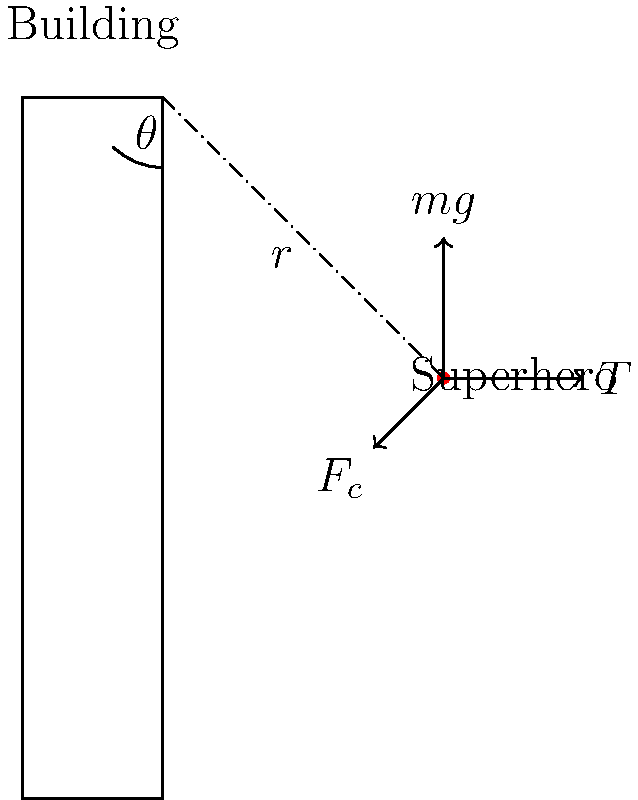Spider-Man is swinging around a building using his web. If his mass is 75 kg and he's swinging in a circular path with a radius of 20 meters at a velocity of 15 m/s, what is the centripetal force needed to maintain this circular motion? Assume g = 9.8 m/s². To solve this problem, we'll use the formula for centripetal force and follow these steps:

1) The formula for centripetal force is:
   $F_c = \frac{mv^2}{r}$

   Where:
   $F_c$ is the centripetal force
   $m$ is the mass of Spider-Man
   $v$ is his velocity
   $r$ is the radius of his circular path

2) We're given:
   $m = 75$ kg
   $v = 15$ m/s
   $r = 20$ m

3) Let's substitute these values into the formula:

   $F_c = \frac{75 \text{ kg} \times (15 \text{ m/s})^2}{20 \text{ m}}$

4) Simplify:
   $F_c = \frac{75 \times 225}{20} = \frac{16875}{20} = 843.75$ N

5) However, we need to consider that part of this force is provided by gravity. The tension in the web (T) minus the component of gravity acting towards the center of the circle (mg cos θ) equals the centripetal force:

   $T - mg \cos \theta = \frac{mv^2}{r}$

6) To find cos θ, we can use the ratio of the vertical component of r to r itself:
   $\cos \theta = \frac{20}{20} = 1$ (Spider-Man is level with the attachment point)

7) Now we can solve for T:
   $T = \frac{mv^2}{r} + mg \cos \theta$
   $T = 843.75 \text{ N} + (75 \text{ kg})(9.8 \text{ m/s}^2)(1)$
   $T = 843.75 \text{ N} + 735 \text{ N} = 1578.75 \text{ N}$

Therefore, the tension in the web, which is the centripetal force needed to maintain the circular motion, is approximately 1578.75 N.
Answer: 1578.75 N 